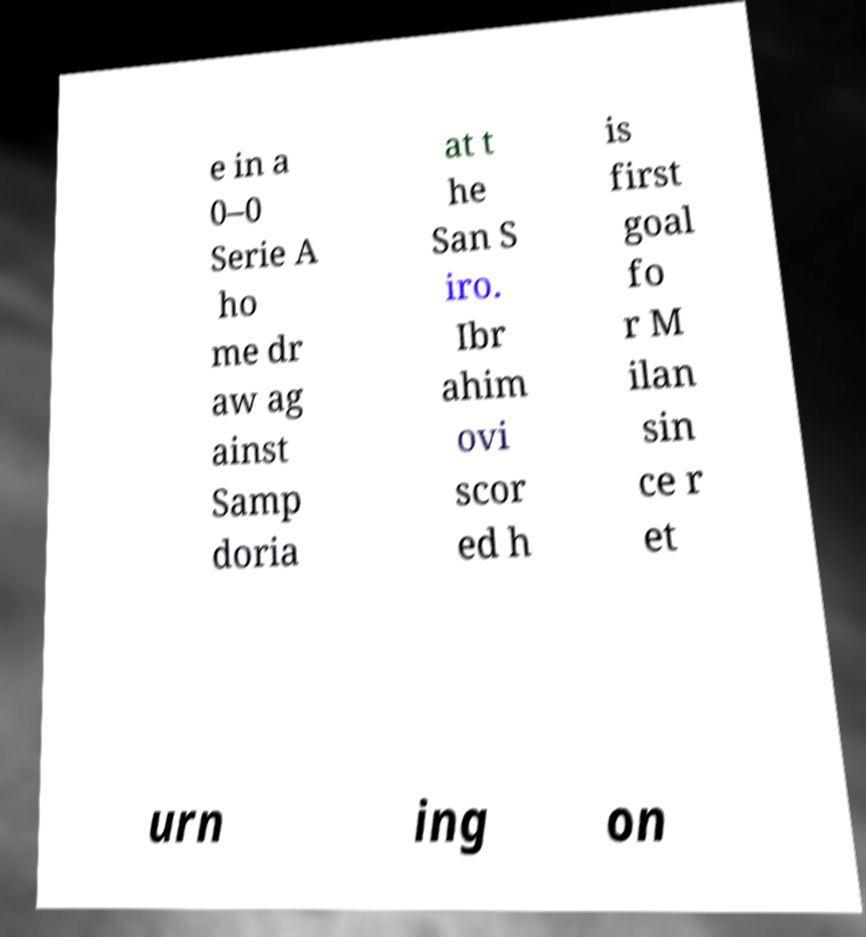Could you assist in decoding the text presented in this image and type it out clearly? e in a 0–0 Serie A ho me dr aw ag ainst Samp doria at t he San S iro. Ibr ahim ovi scor ed h is first goal fo r M ilan sin ce r et urn ing on 